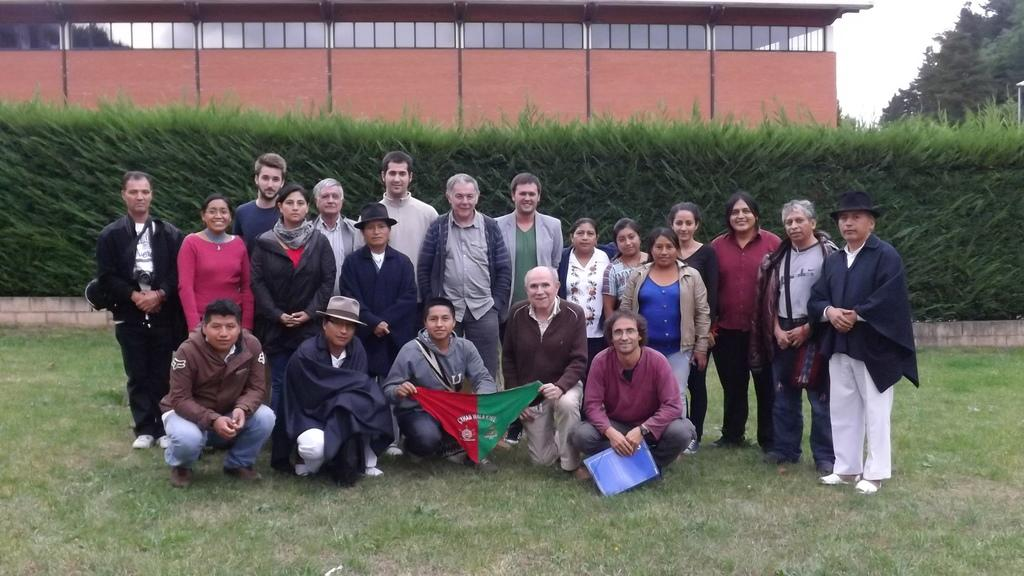What is the main subject of the image? The main subject of the image is a group of people. Where are the people located in the image? The people are in the center of the image. What type of environment are the people in? The people are on a grassland. What can be seen in the background of the image? There is greenery and a building in the background of the image. What type of drum can be heard in the image? There is no drum present in the image, and therefore no sound can be heard. 